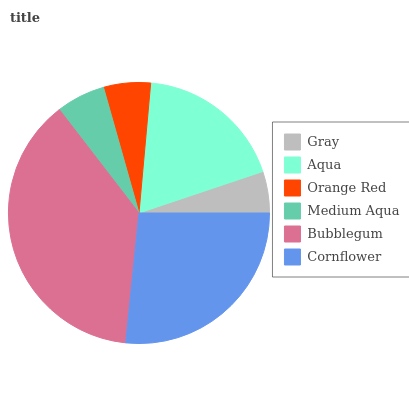Is Gray the minimum?
Answer yes or no. Yes. Is Bubblegum the maximum?
Answer yes or no. Yes. Is Aqua the minimum?
Answer yes or no. No. Is Aqua the maximum?
Answer yes or no. No. Is Aqua greater than Gray?
Answer yes or no. Yes. Is Gray less than Aqua?
Answer yes or no. Yes. Is Gray greater than Aqua?
Answer yes or no. No. Is Aqua less than Gray?
Answer yes or no. No. Is Aqua the high median?
Answer yes or no. Yes. Is Medium Aqua the low median?
Answer yes or no. Yes. Is Gray the high median?
Answer yes or no. No. Is Cornflower the low median?
Answer yes or no. No. 